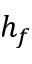Convert formula to latex. <formula><loc_0><loc_0><loc_500><loc_500>h _ { f }</formula> 